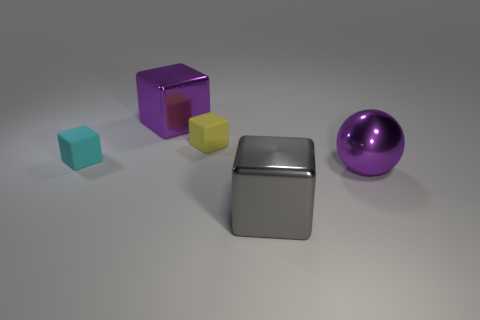Add 1 small yellow objects. How many objects exist? 6 Subtract all cubes. How many objects are left? 1 Subtract all tiny yellow things. Subtract all large red cubes. How many objects are left? 4 Add 5 small yellow blocks. How many small yellow blocks are left? 6 Add 3 yellow objects. How many yellow objects exist? 4 Subtract 1 yellow cubes. How many objects are left? 4 